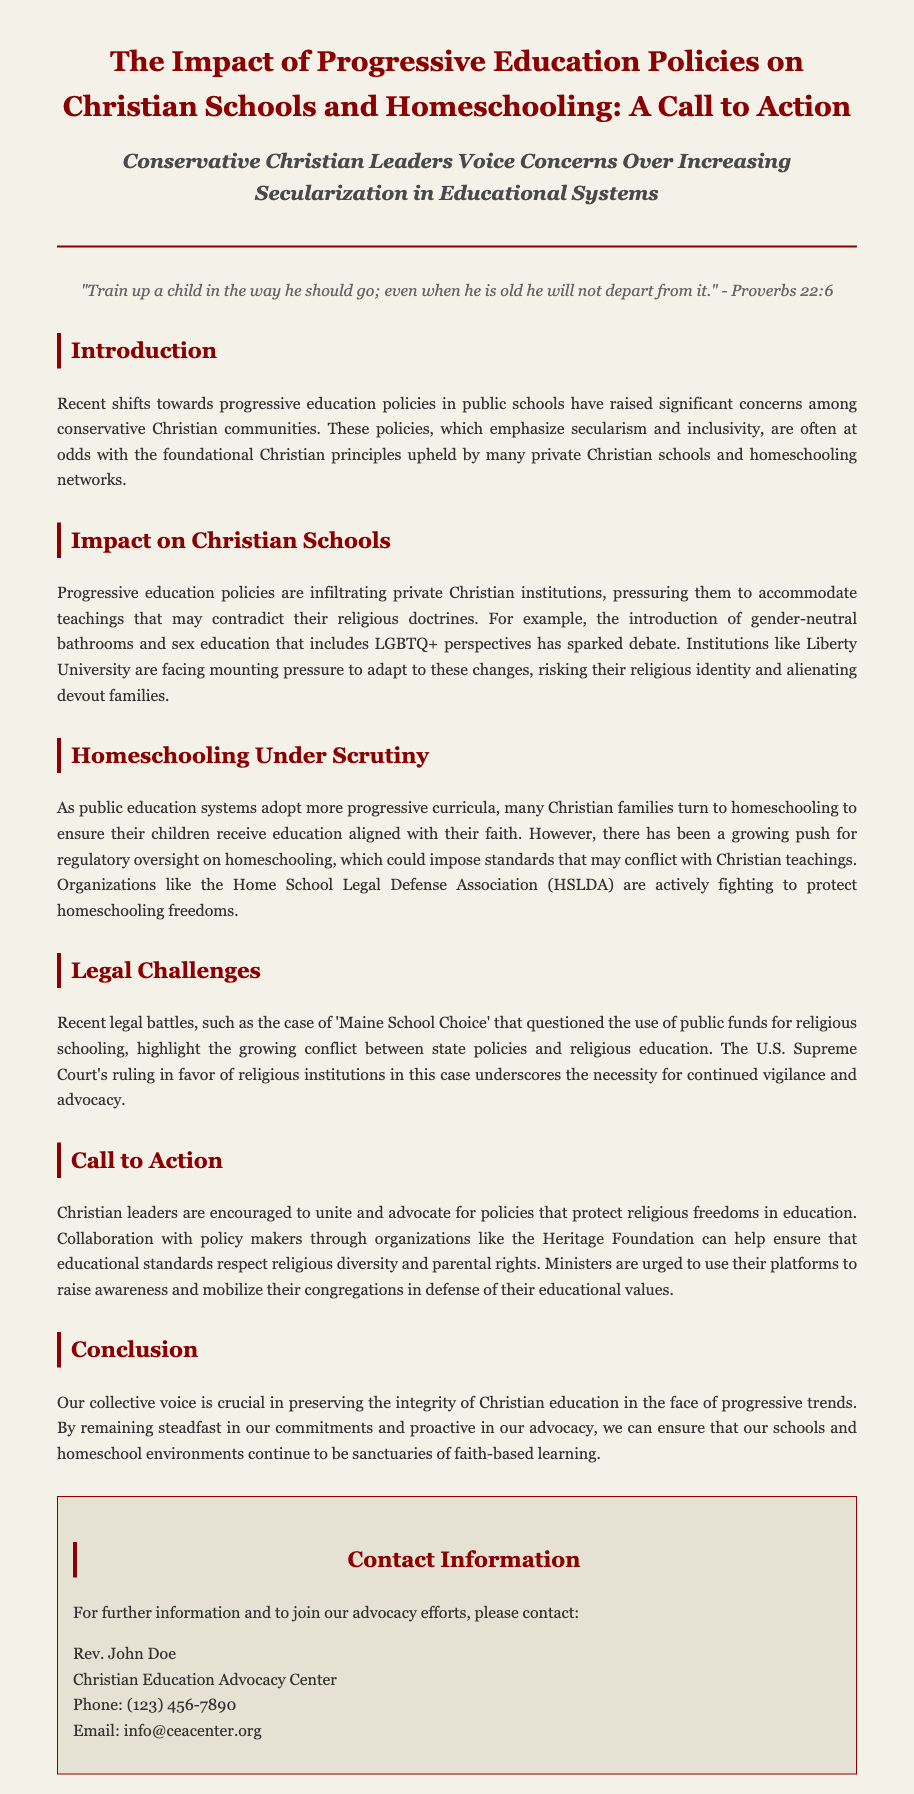What is the title of the press release? The title is prominently displayed at the top of the document and encapsulates the main topic addressed.
Answer: The Impact of Progressive Education Policies on Christian Schools and Homeschooling: A Call to Action Who is encouraged to unite and advocate for policies? This information is found in the section discussing the call to action, emphasizing collective efforts among leaders.
Answer: Christian leaders What legal case is mentioned in the press release? The document highlights a significant legal battle relevant to religious education, providing context for current challenges.
Answer: Maine School Choice What organization is fighting to protect homeschooling freedoms? The document references an organization dedicated to defending parental rights in education contexts.
Answer: Home School Legal Defense Association (HSLDA) What scripture is included in the document? A specific verse is quoted to reinforce the overall message and significance of Christian education.
Answer: "Train up a child in the way he should go; even when he is old he will not depart from it." - Proverbs 22:6 What issue do progressive education policies introduce to Christian schools? The press release specifically discusses challenges posed by new policies regarding curriculum and institutional practices.
Answer: Gender-neutral bathrooms and sex education including LGBTQ+ perspectives 